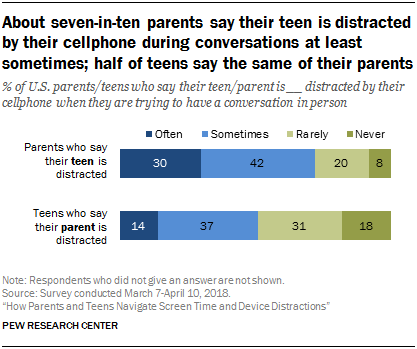List a handful of essential elements in this visual. According to a recent survey, 30% of teenagers are choosing to vaccinate regularly. The most popular option in both categories is sometimes 